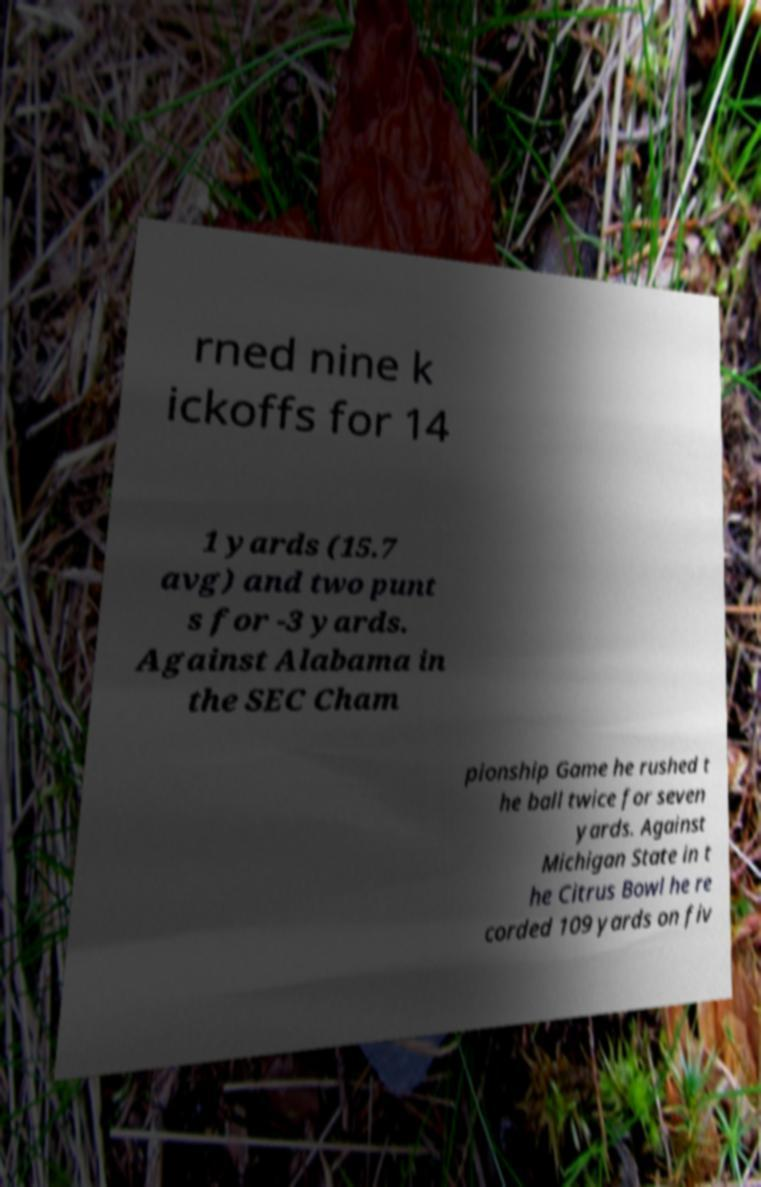For documentation purposes, I need the text within this image transcribed. Could you provide that? rned nine k ickoffs for 14 1 yards (15.7 avg) and two punt s for -3 yards. Against Alabama in the SEC Cham pionship Game he rushed t he ball twice for seven yards. Against Michigan State in t he Citrus Bowl he re corded 109 yards on fiv 